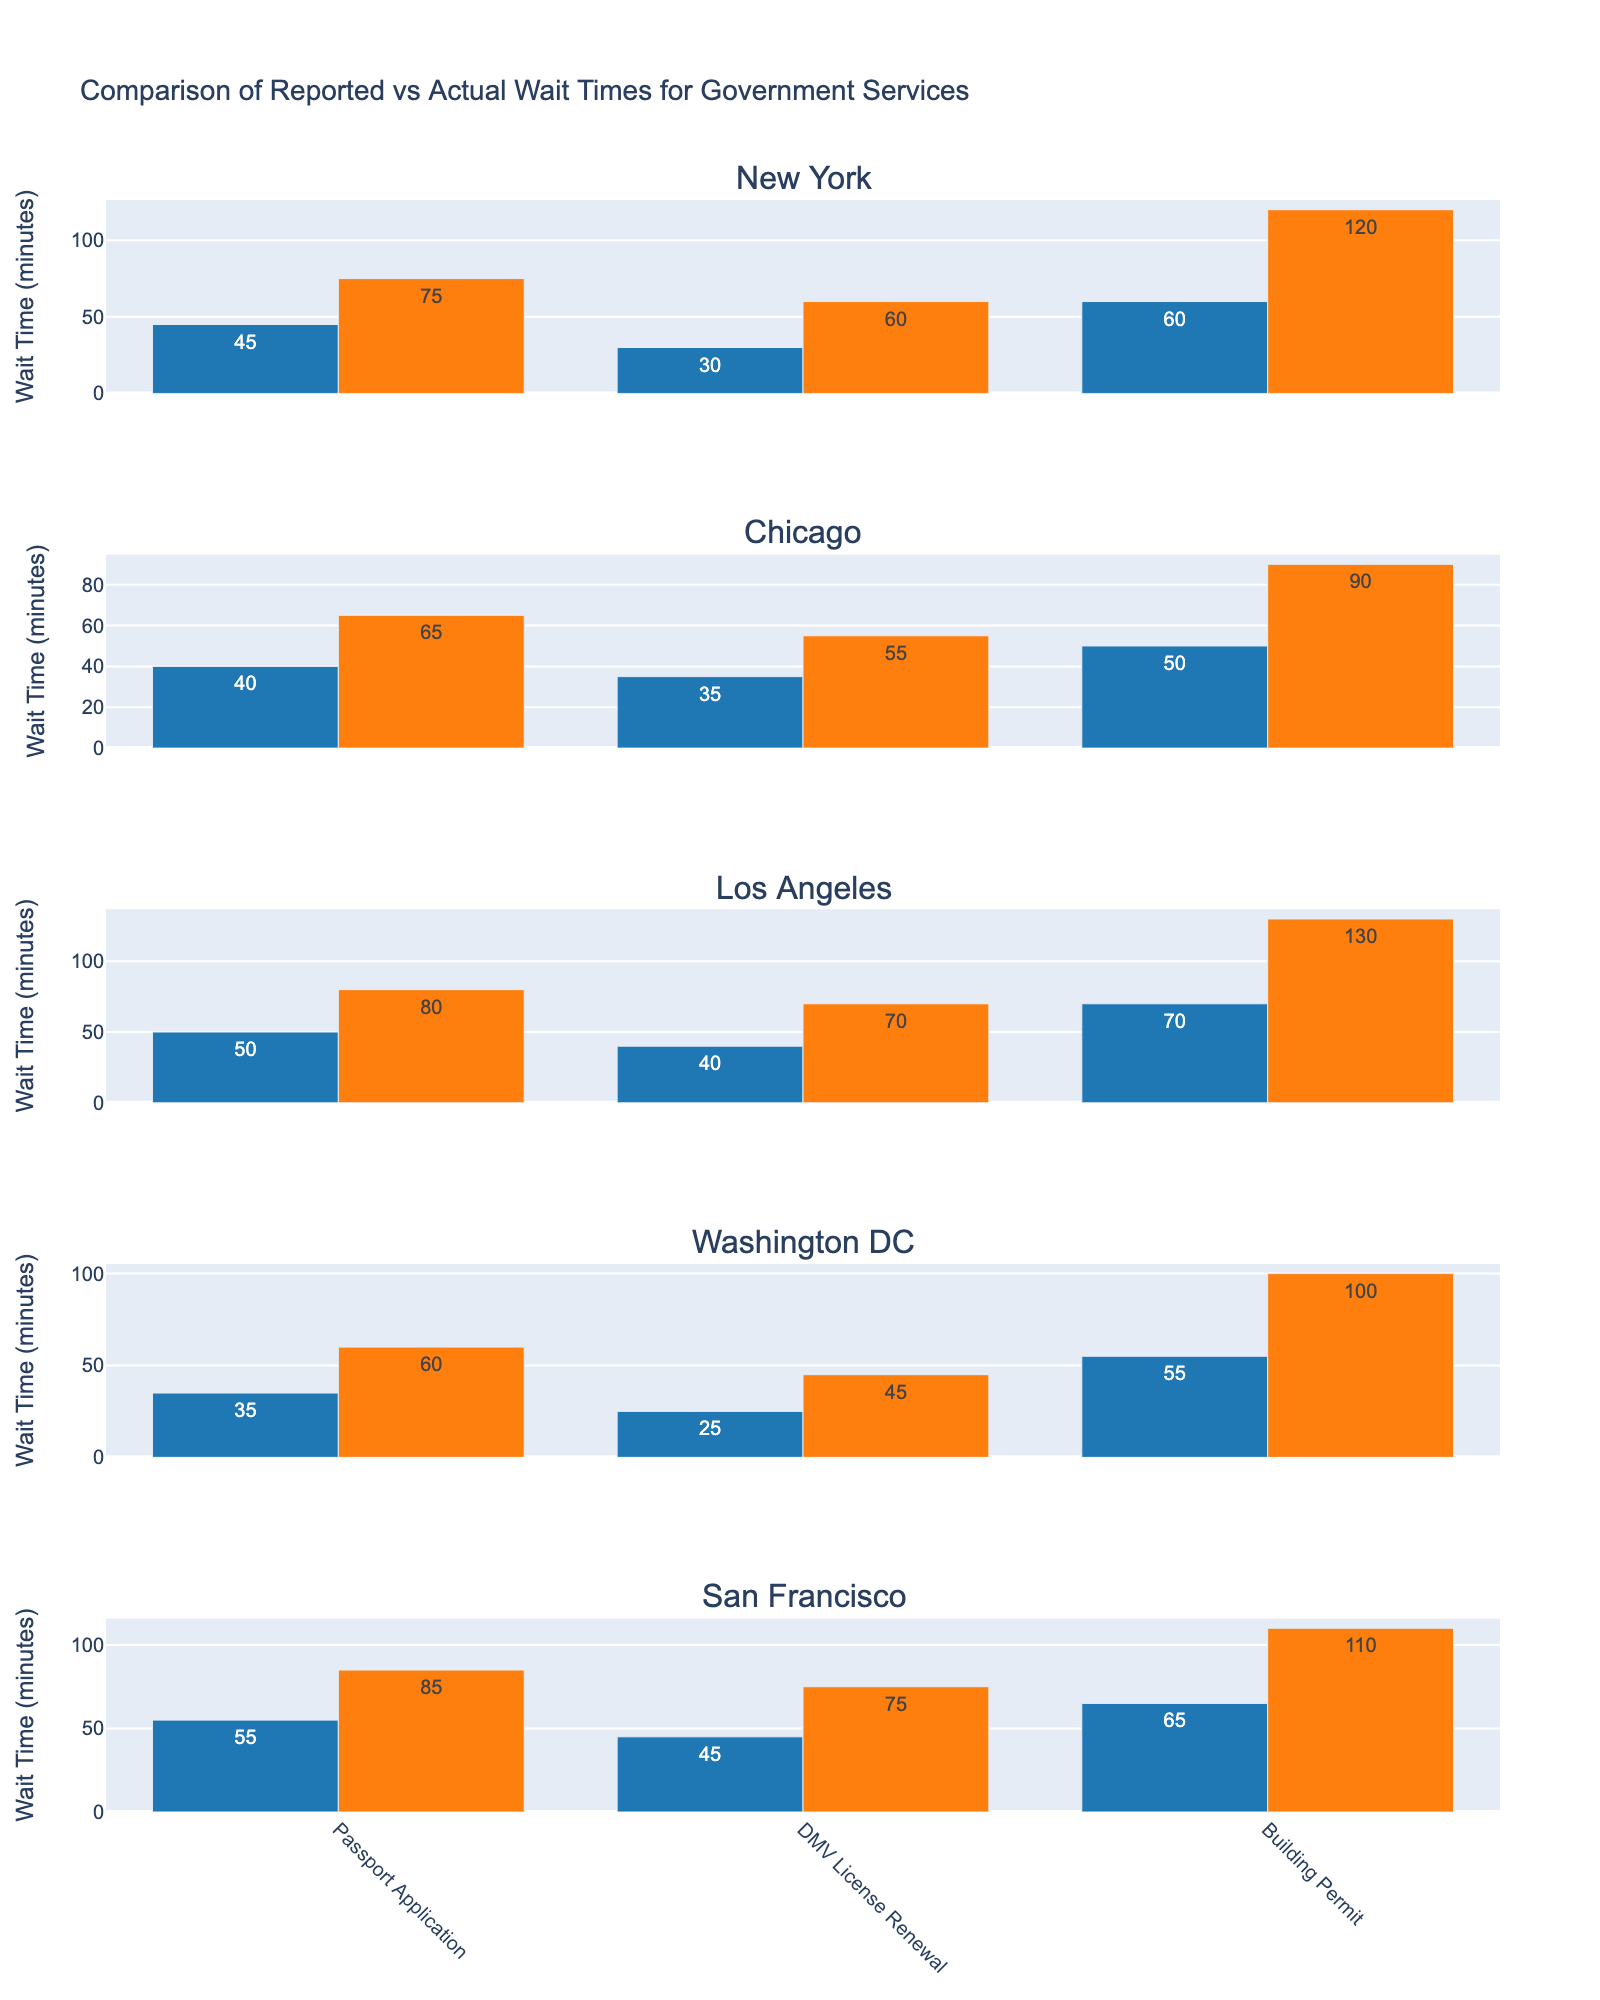Which city has the highest reported wait time for DMV License Renewal? Look at the subplots and locate the bar heights for DMV License Renewal under "Reported Wait Time". Compare these heights across all cities.
Answer: Los Angeles What is the difference between reported and actual wait times for Passport Application in New York? First, find the reported and actual wait times for Passport Application in New York. Subtract the reported wait time from the actual wait time: 75 - 45.
Answer: 30 minutes How many services are depicted for each city? Examine the x-axis labels under each subplot. Each subplot represents a city and lists the services evaluated within that city. Count these services.
Answer: 3 Which service has the largest discrepancy between reported and actual wait times in San Francisco? Look at the subplots for San Francisco and compare the height difference between the reported and actual wait time bars for each service.
Answer: Building Permit Are there any services where the reported wait times are equal to the actual wait times? Scan across all subplots and check if any pair of bars (one representing reported and one representing actual wait times) have the same height.
Answer: No Which city has the smallest reported wait time for Passport Application? Check the heights of the bars representing reported wait times for Passport Application across all cities. Identify the shortest one.
Answer: Washington DC What is the combined reported wait time for all services in Chicago? Add the reported wait times for all services in Chicago: 40 (Passport Application) + 35 (DMV License Renewal) + 50 (Building Permit).
Answer: 125 minutes How does the actual wait time for Building Permit compare between New York and Los Angeles? Find the Actual Wait Time bars for Building Permit in both New York and Los Angeles. Compare their heights to see which is taller.
Answer: Los Angeles has a longer wait time What is the average actual wait time for Passport Application across all cities? Sum the actual wait times for Passport Application across all cities and divide by the number of cities: (75 + 65 + 80 + 60 + 85) / 5.
Answer: 73 minutes 